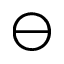<formula> <loc_0><loc_0><loc_500><loc_500>\ominus</formula> 